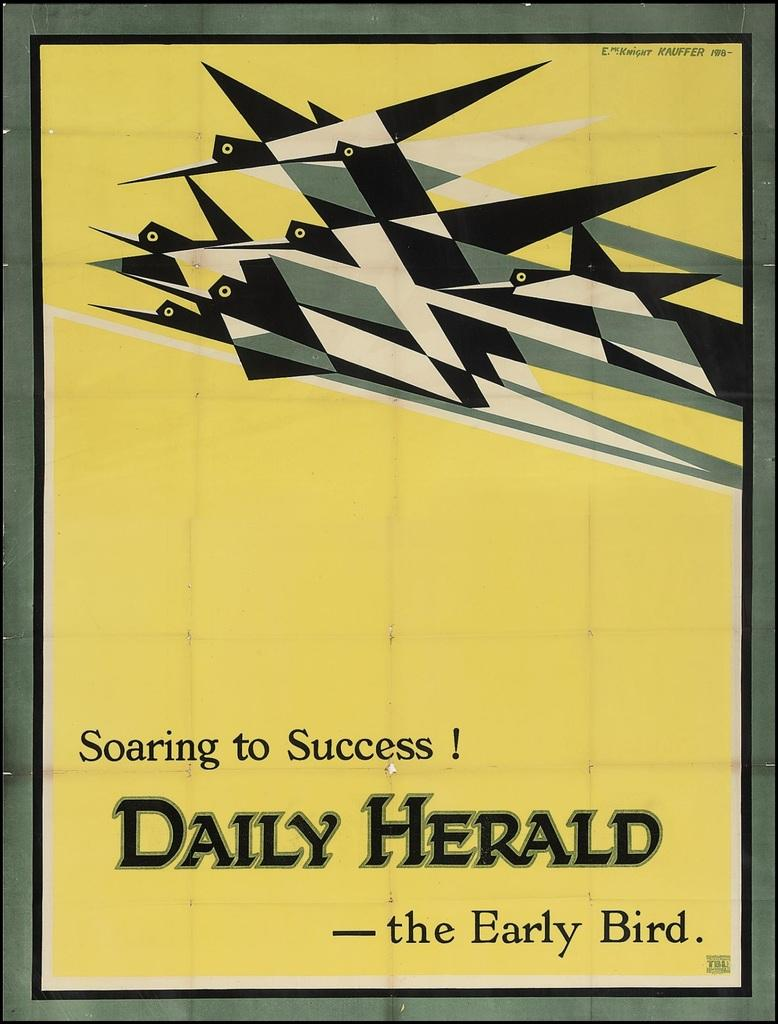<image>
Summarize the visual content of the image. A book with yellow cover titled Soaring to Success! Daily Herald. 